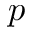Convert formula to latex. <formula><loc_0><loc_0><loc_500><loc_500>p</formula> 